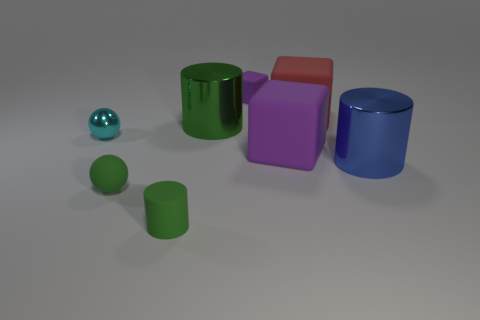What is the shape of the object that is the same color as the tiny matte block?
Keep it short and to the point. Cube. How many green rubber spheres are behind the shiny thing in front of the ball behind the big blue shiny object?
Ensure brevity in your answer.  0. What number of purple things are either shiny spheres or matte things?
Provide a succinct answer. 2. There is a rubber thing left of the tiny cylinder; what shape is it?
Your response must be concise. Sphere. What color is the cube that is the same size as the cyan metal sphere?
Make the answer very short. Purple. There is a large green shiny thing; does it have the same shape as the tiny green object in front of the small rubber ball?
Your answer should be compact. Yes. The purple thing on the left side of the purple cube that is in front of the large shiny thing that is left of the large blue shiny object is made of what material?
Your response must be concise. Rubber. How many big objects are either purple things or yellow shiny spheres?
Offer a terse response. 1. How many other objects are there of the same size as the red cube?
Make the answer very short. 3. Is the shape of the rubber object behind the red rubber object the same as  the large red matte thing?
Offer a terse response. Yes. 